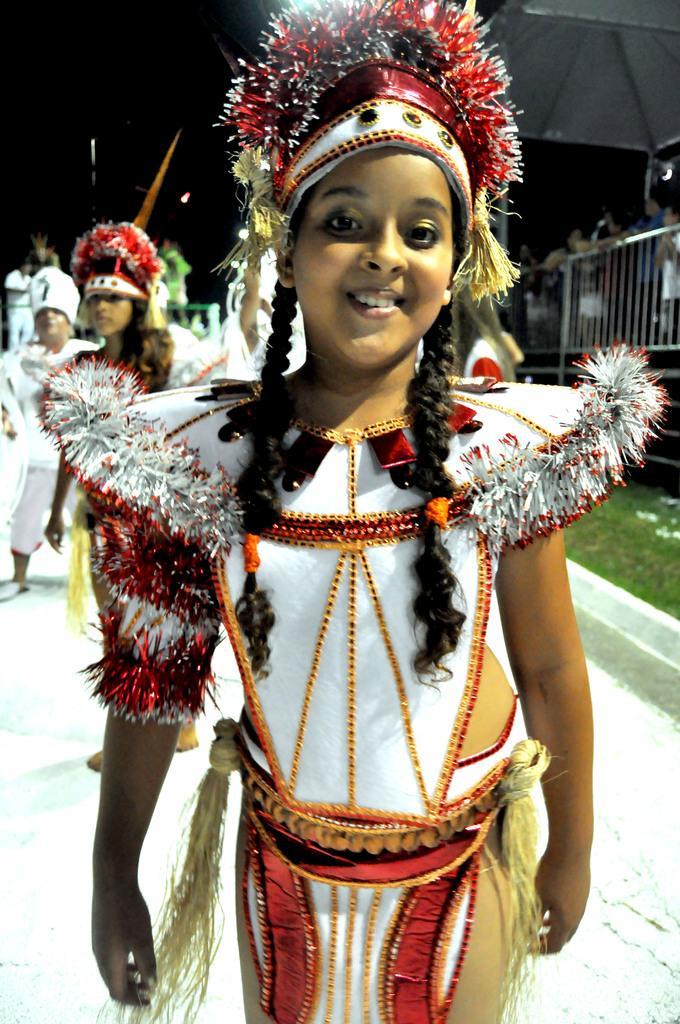In one or two sentences, can you explain what this image depicts? In this image I can see few people and I can see all of them are wearing costumes. On the right side of this image I can see grass, railing, a white colour thing and few more people. I can also see this image is little bit blurry in the background. 